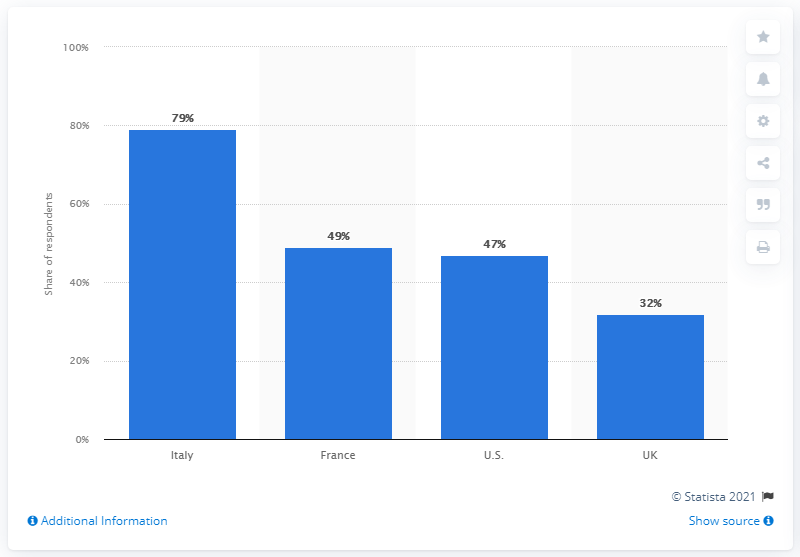Specify some key components in this picture. According to a survey, 79% of consumers in Italy reported that they had decreased their spending on day-to-day in-store purchases due to the COVID-19 pandemic. 